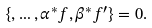<formula> <loc_0><loc_0><loc_500><loc_500>\{ , \dots , \alpha ^ { * } f , \beta ^ { * } f ^ { \prime } \} = 0 .</formula> 